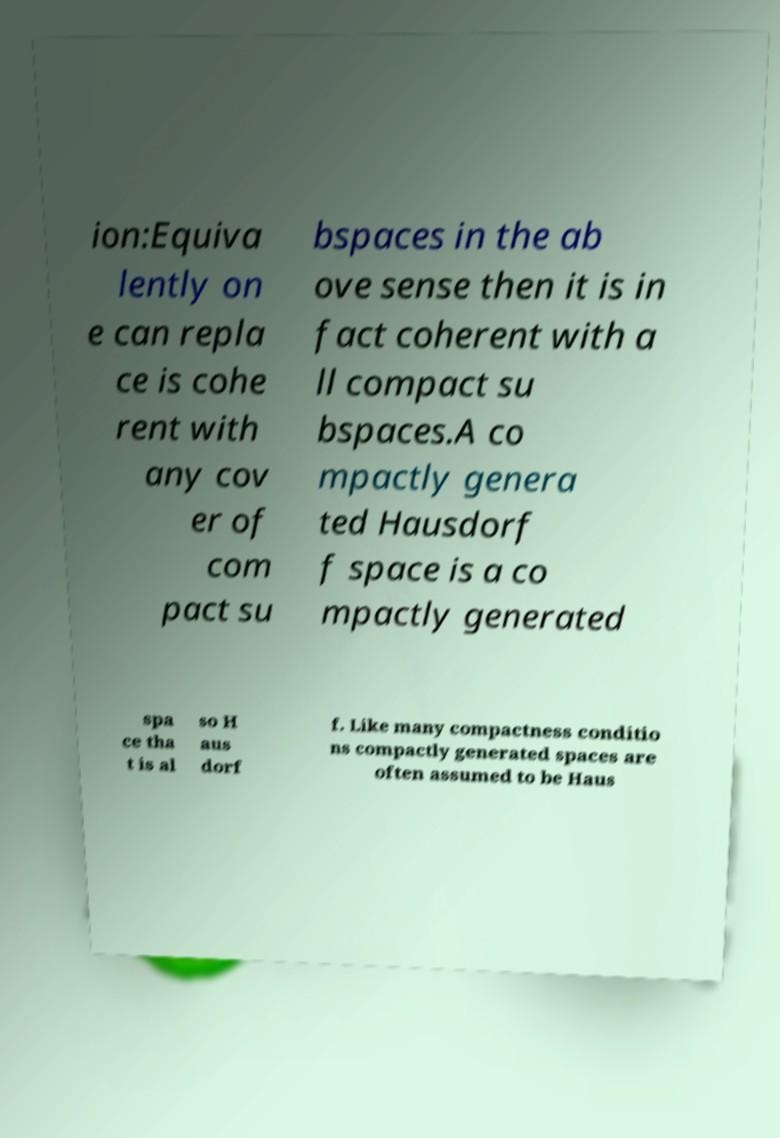Please identify and transcribe the text found in this image. ion:Equiva lently on e can repla ce is cohe rent with any cov er of com pact su bspaces in the ab ove sense then it is in fact coherent with a ll compact su bspaces.A co mpactly genera ted Hausdorf f space is a co mpactly generated spa ce tha t is al so H aus dorf f. Like many compactness conditio ns compactly generated spaces are often assumed to be Haus 